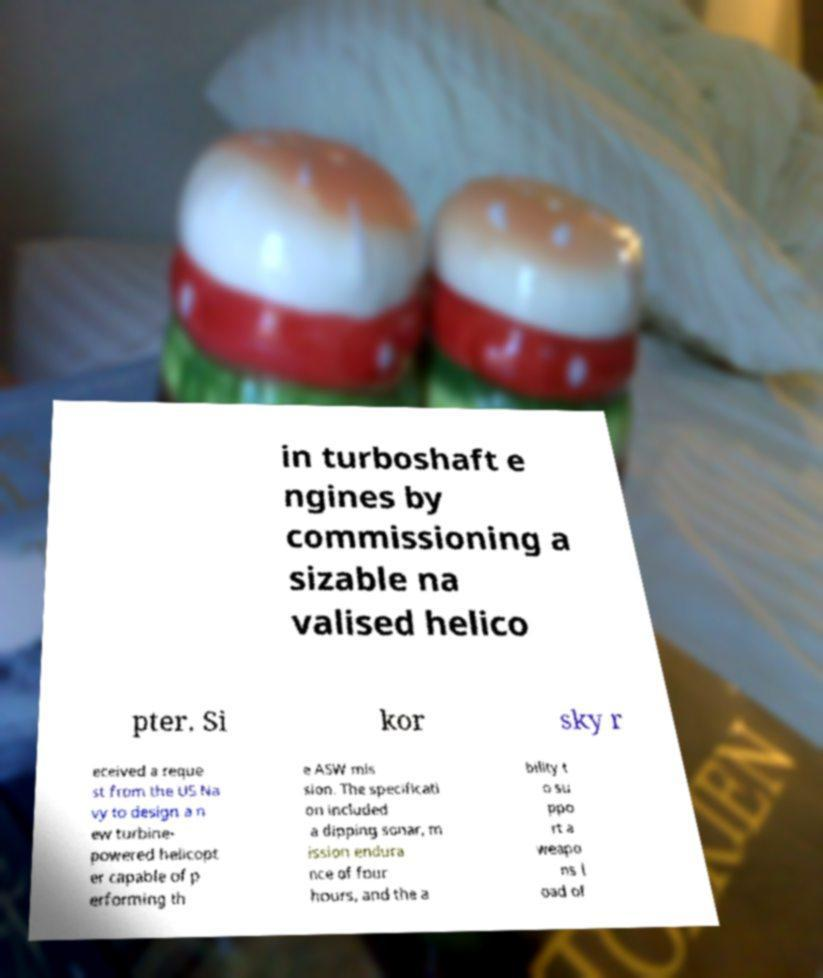For documentation purposes, I need the text within this image transcribed. Could you provide that? in turboshaft e ngines by commissioning a sizable na valised helico pter. Si kor sky r eceived a reque st from the US Na vy to design a n ew turbine- powered helicopt er capable of p erforming th e ASW mis sion. The specificati on included a dipping sonar, m ission endura nce of four hours, and the a bility t o su ppo rt a weapo ns l oad of 